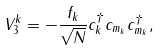Convert formula to latex. <formula><loc_0><loc_0><loc_500><loc_500>V _ { 3 } ^ { k } = - \frac { f _ { k } } { \sqrt { N } } c _ { k } ^ { \dagger } c _ { m _ { k } } c _ { m _ { k } } ^ { \dagger } ,</formula> 